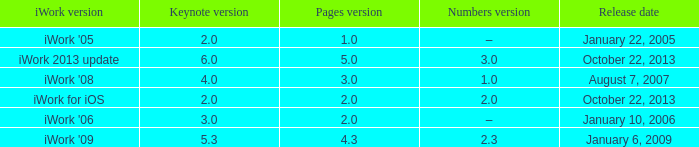What version of iWork was released on October 22, 2013 with a pages version greater than 2? Iwork 2013 update. 